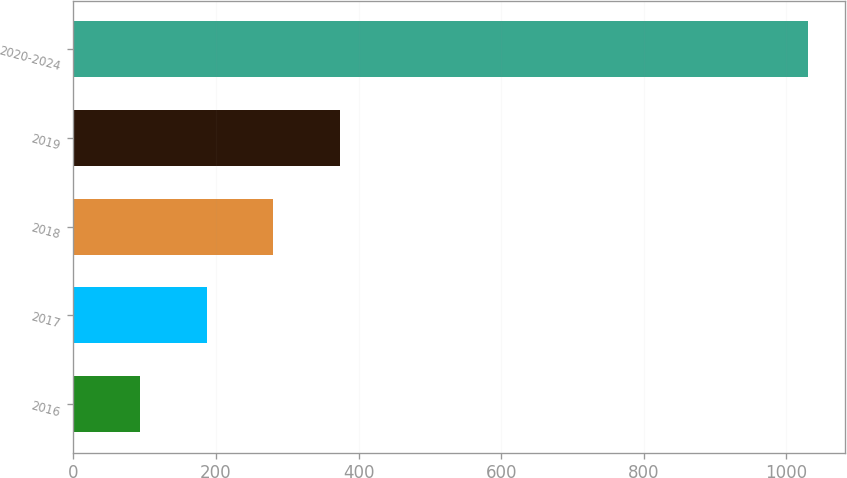<chart> <loc_0><loc_0><loc_500><loc_500><bar_chart><fcel>2016<fcel>2017<fcel>2018<fcel>2019<fcel>2020-2024<nl><fcel>93<fcel>186.7<fcel>280.4<fcel>374.1<fcel>1030<nl></chart> 